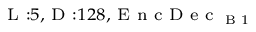<formula> <loc_0><loc_0><loc_500><loc_500>_ { L \colon 5 , D \colon 1 2 8 , E n c D e c _ { B 1 } }</formula> 